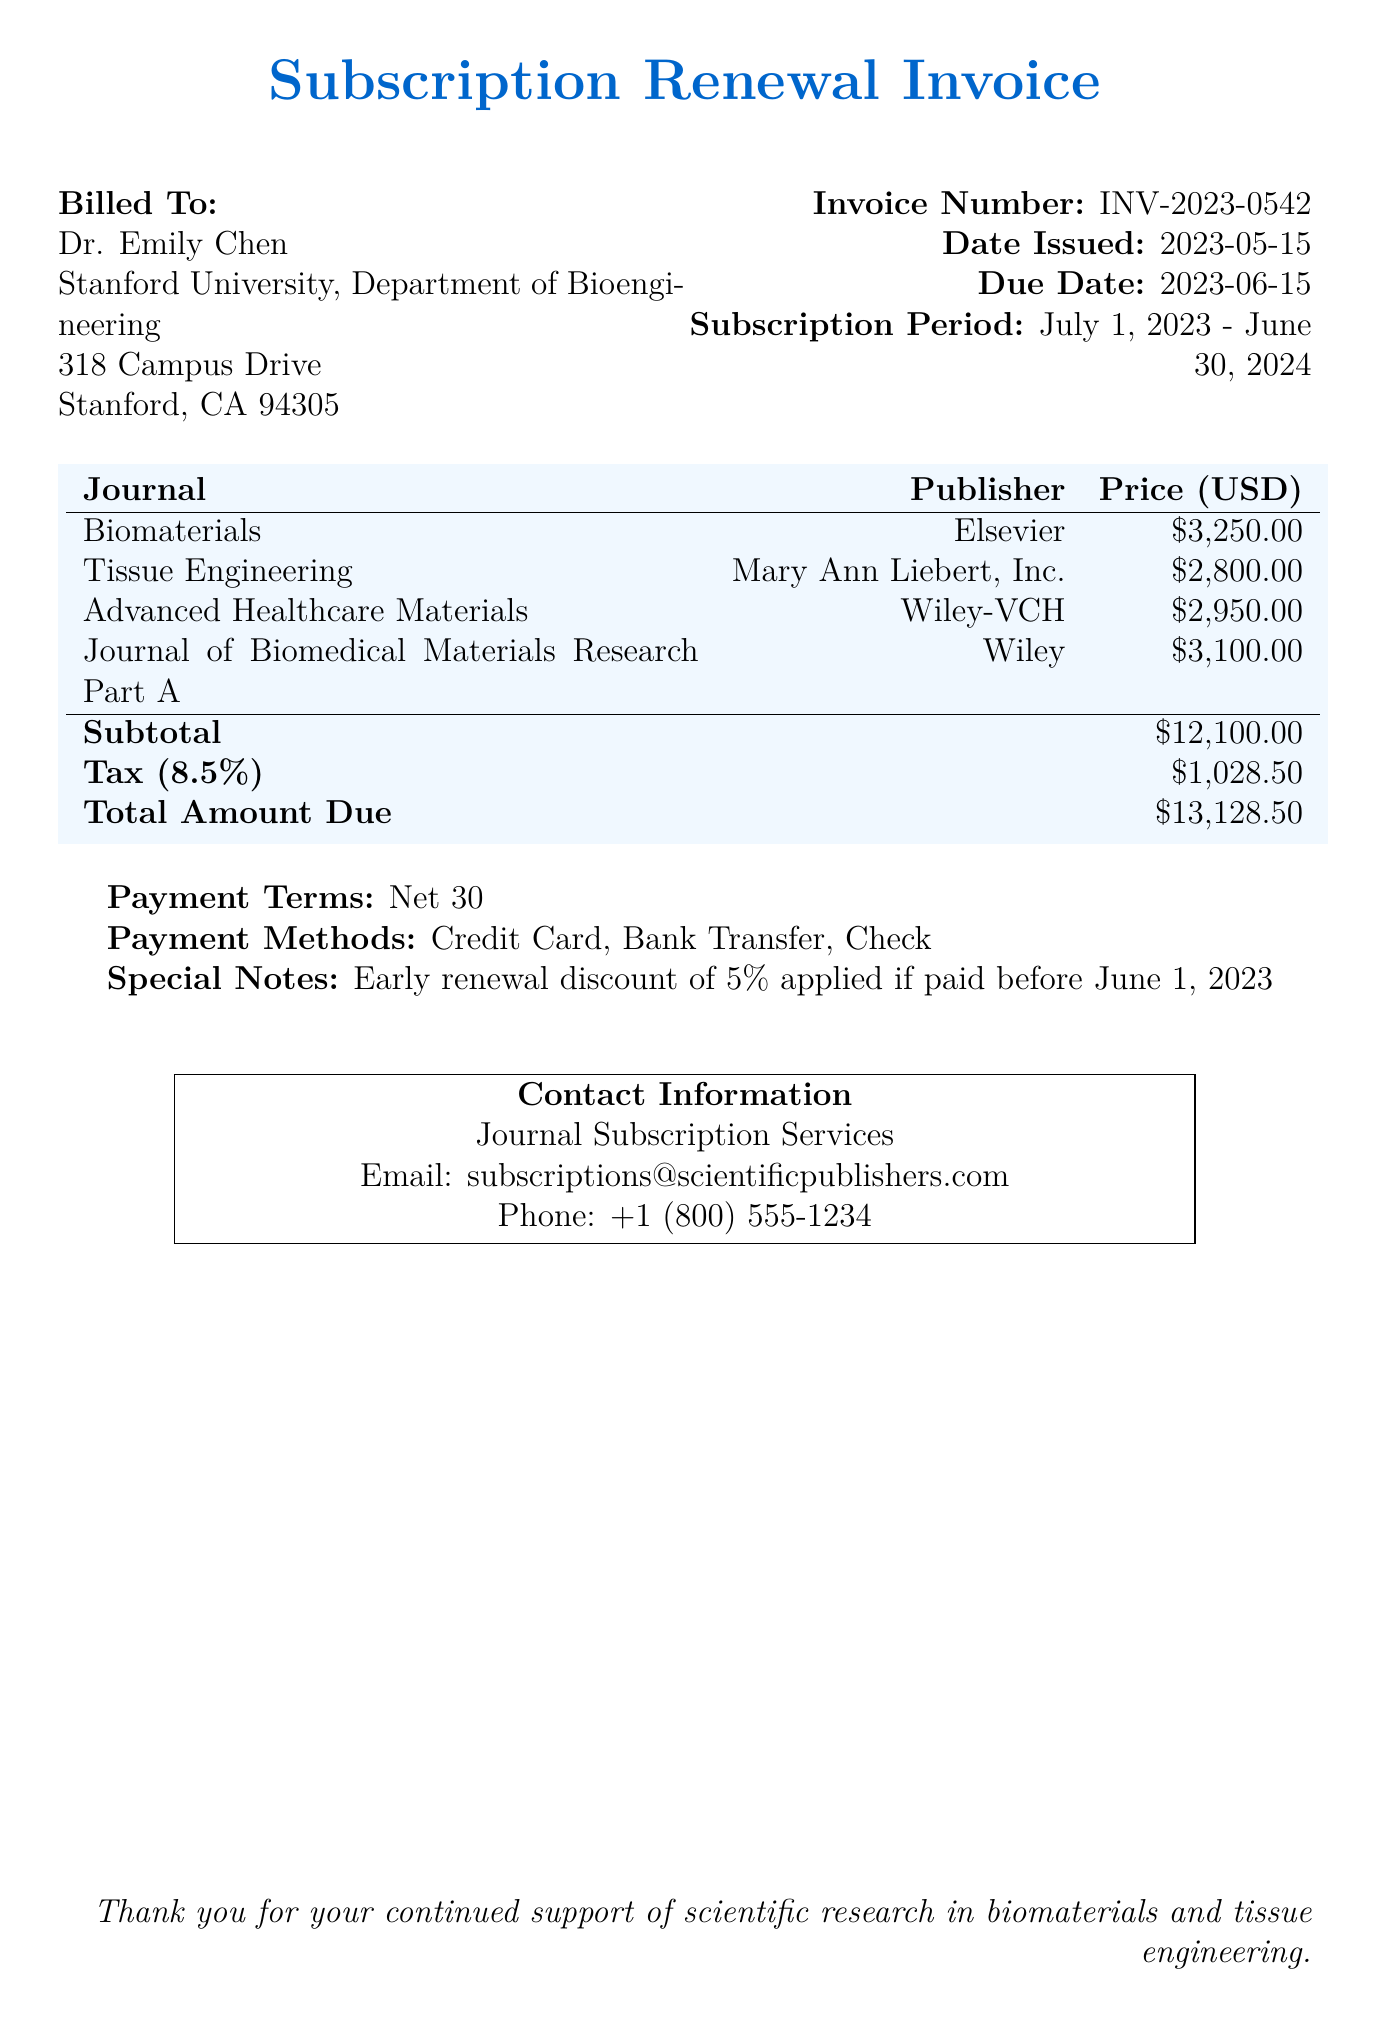What is the invoice number? The invoice number is clearly stated in the document, allowing for easy reference in correspondence.
Answer: INV-2023-0542 What is the due date for payment? The due date is provided to ensure timely payment and avoid any potential late fees.
Answer: 2023-06-15 Who is the billed party? The document specifies the individual or entity being billed for the subscription, which is important for record-keeping.
Answer: Dr. Emily Chen What is the total amount due? The total amount due summarizes all charges, including taxes, making it essential for payment planning.
Answer: $13,128.50 What is the tax rate applied? The tax rate is mentioned to clarify how much tax is added to the subtotal, which is critical for financial considerations.
Answer: 8.5% What is the subscription period? The subscription period indicates the duration for which the journals will be accessible, vital for understanding timeframes.
Answer: July 1, 2023 - June 30, 2024 Is there an early renewal discount? The document offers an incentive for early payment, which can benefit budgeting decisions.
Answer: 5% What is the payment term? Payment terms outline the conditions under which payment is expected, crucial for managing cash flow.
Answer: Net 30 What is the publisher of the journal "Biomaterials"? This question clarifies the relationship between the journal and its publisher, which can influence the reputation and accessibility of research.
Answer: Elsevier 